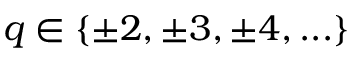<formula> <loc_0><loc_0><loc_500><loc_500>q \in \{ \pm 2 , \pm 3 , \pm 4 , \dots \}</formula> 